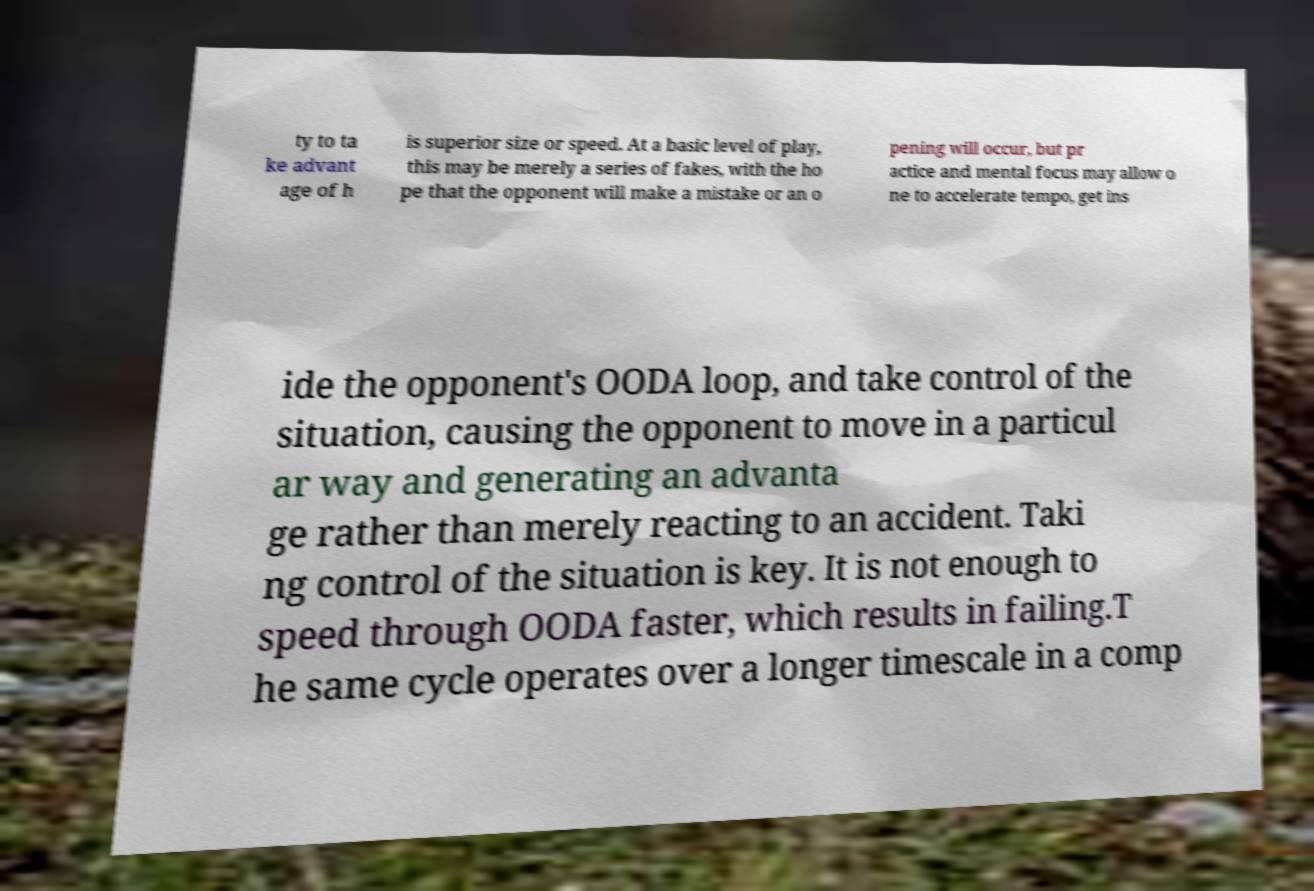Could you extract and type out the text from this image? ty to ta ke advant age of h is superior size or speed. At a basic level of play, this may be merely a series of fakes, with the ho pe that the opponent will make a mistake or an o pening will occur, but pr actice and mental focus may allow o ne to accelerate tempo, get ins ide the opponent's OODA loop, and take control of the situation, causing the opponent to move in a particul ar way and generating an advanta ge rather than merely reacting to an accident. Taki ng control of the situation is key. It is not enough to speed through OODA faster, which results in failing.T he same cycle operates over a longer timescale in a comp 